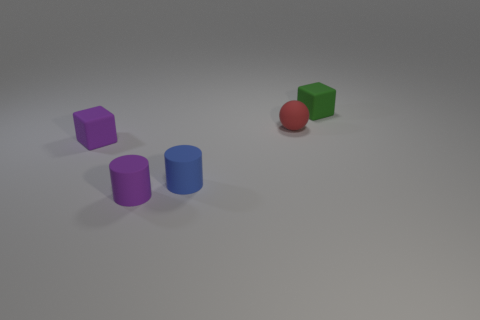Add 2 tiny purple rubber cubes. How many objects exist? 7 Subtract all balls. How many objects are left? 4 Add 2 small matte things. How many small matte things exist? 7 Subtract 1 green cubes. How many objects are left? 4 Subtract all big red metallic blocks. Subtract all small blue things. How many objects are left? 4 Add 4 small green objects. How many small green objects are left? 5 